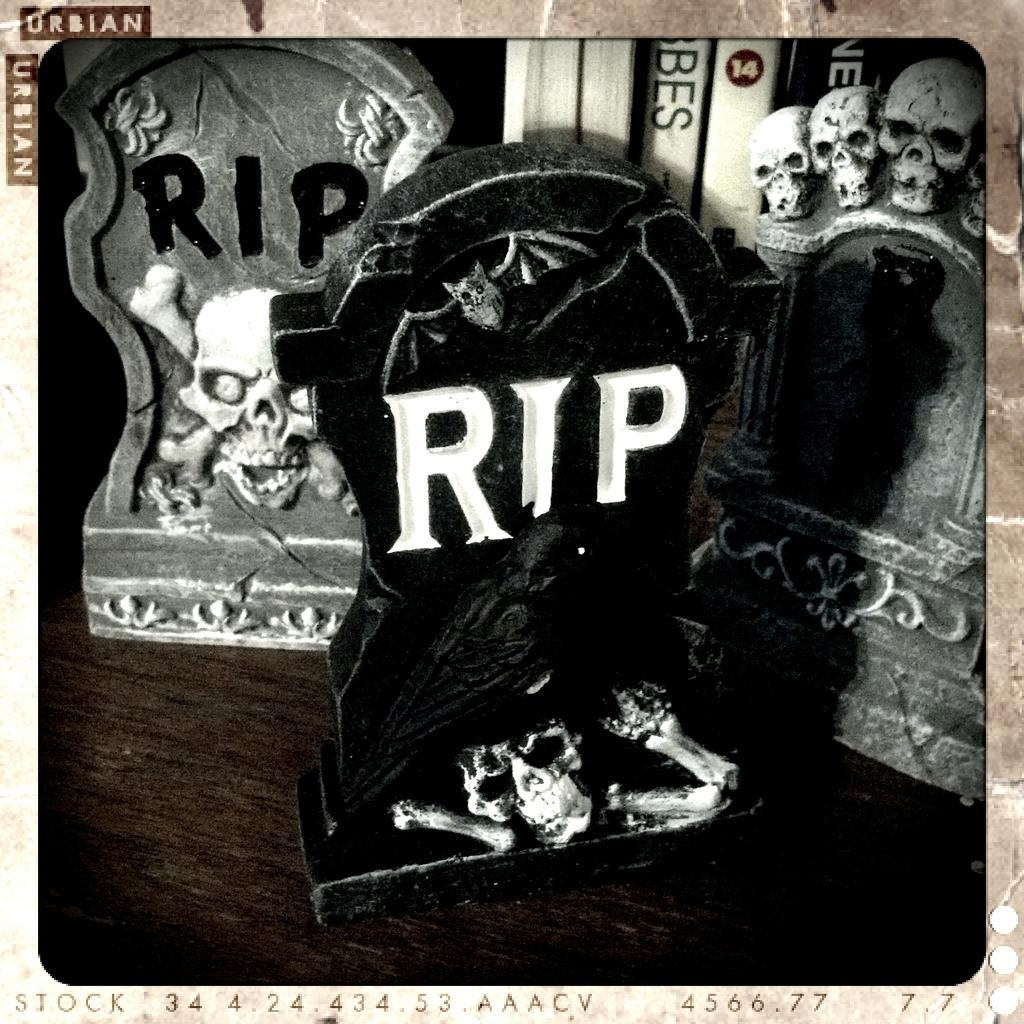<image>
Describe the image concisely. Three different small grave stones with the text rip on each of them. 